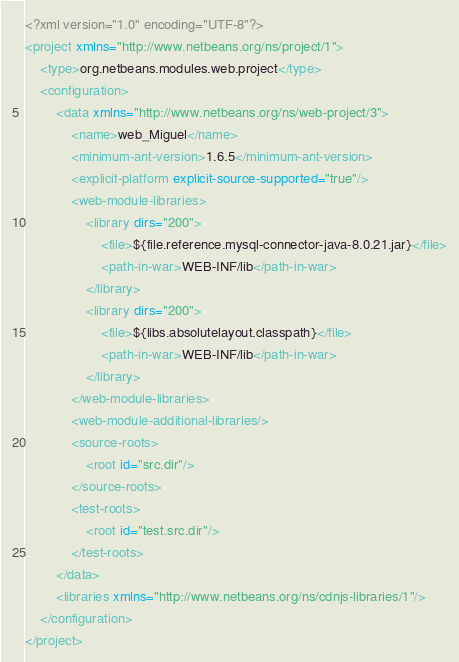Convert code to text. <code><loc_0><loc_0><loc_500><loc_500><_XML_><?xml version="1.0" encoding="UTF-8"?>
<project xmlns="http://www.netbeans.org/ns/project/1">
    <type>org.netbeans.modules.web.project</type>
    <configuration>
        <data xmlns="http://www.netbeans.org/ns/web-project/3">
            <name>web_Miguel</name>
            <minimum-ant-version>1.6.5</minimum-ant-version>
            <explicit-platform explicit-source-supported="true"/>
            <web-module-libraries>
                <library dirs="200">
                    <file>${file.reference.mysql-connector-java-8.0.21.jar}</file>
                    <path-in-war>WEB-INF/lib</path-in-war>
                </library>
                <library dirs="200">
                    <file>${libs.absolutelayout.classpath}</file>
                    <path-in-war>WEB-INF/lib</path-in-war>
                </library>
            </web-module-libraries>
            <web-module-additional-libraries/>
            <source-roots>
                <root id="src.dir"/>
            </source-roots>
            <test-roots>
                <root id="test.src.dir"/>
            </test-roots>
        </data>
        <libraries xmlns="http://www.netbeans.org/ns/cdnjs-libraries/1"/>
    </configuration>
</project>
</code> 